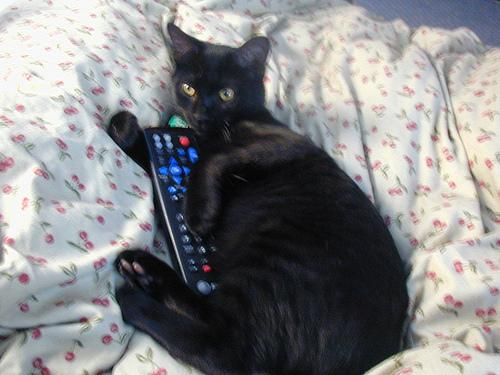In a few words, describe the overall emotion portrayed by the image. Relaxed and comfortable atmosphere with a cute and amusing cat interacting with a remote control. How many paws does the cat have, and what are some characteristics of them? The cat has two back paws and one right forepaw visible; pinkypurply paw pads are on one paw and it's curled under on the other. Express what the cat is doing with the remote control. The cat is cozying up to the remote control, using its paw to press the buttons and interact with the device. Describe the main elements and colors of the remote control in the image. The remote control is black, with blue buttons and a red power button. It also has a grey button and is placed under the cat's paw. What object is the cat interacting with, and what are its main colors? The cat is holding a remote control that is black with blue buttons and a red power button. Provide the details of the cat's face, including colors of its eyes and nose. The cat has yellow gold eyes and a black nose, with green eyes also visible on its face. Mention the pattern and colors of the cherries on the blanket. The cherries on the blanket are red with green stems, scattered on a wrinkly white background. Identify the background on which the image objects are placed. The objects are placed on a blanket with red cherries on a wrinkly white ground. 